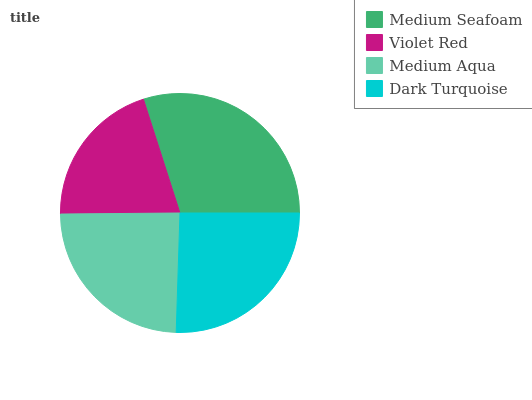Is Violet Red the minimum?
Answer yes or no. Yes. Is Medium Seafoam the maximum?
Answer yes or no. Yes. Is Medium Aqua the minimum?
Answer yes or no. No. Is Medium Aqua the maximum?
Answer yes or no. No. Is Medium Aqua greater than Violet Red?
Answer yes or no. Yes. Is Violet Red less than Medium Aqua?
Answer yes or no. Yes. Is Violet Red greater than Medium Aqua?
Answer yes or no. No. Is Medium Aqua less than Violet Red?
Answer yes or no. No. Is Dark Turquoise the high median?
Answer yes or no. Yes. Is Medium Aqua the low median?
Answer yes or no. Yes. Is Medium Seafoam the high median?
Answer yes or no. No. Is Medium Seafoam the low median?
Answer yes or no. No. 